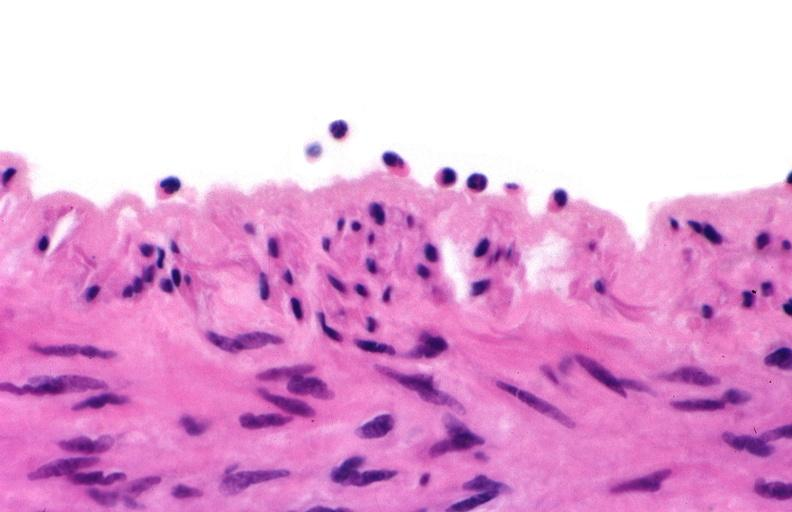what is present?
Answer the question using a single word or phrase. Vasculature 